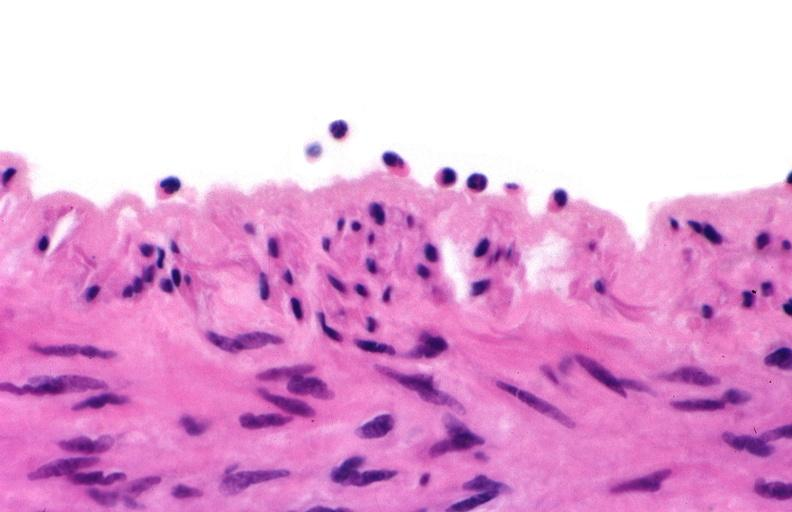what is present?
Answer the question using a single word or phrase. Vasculature 